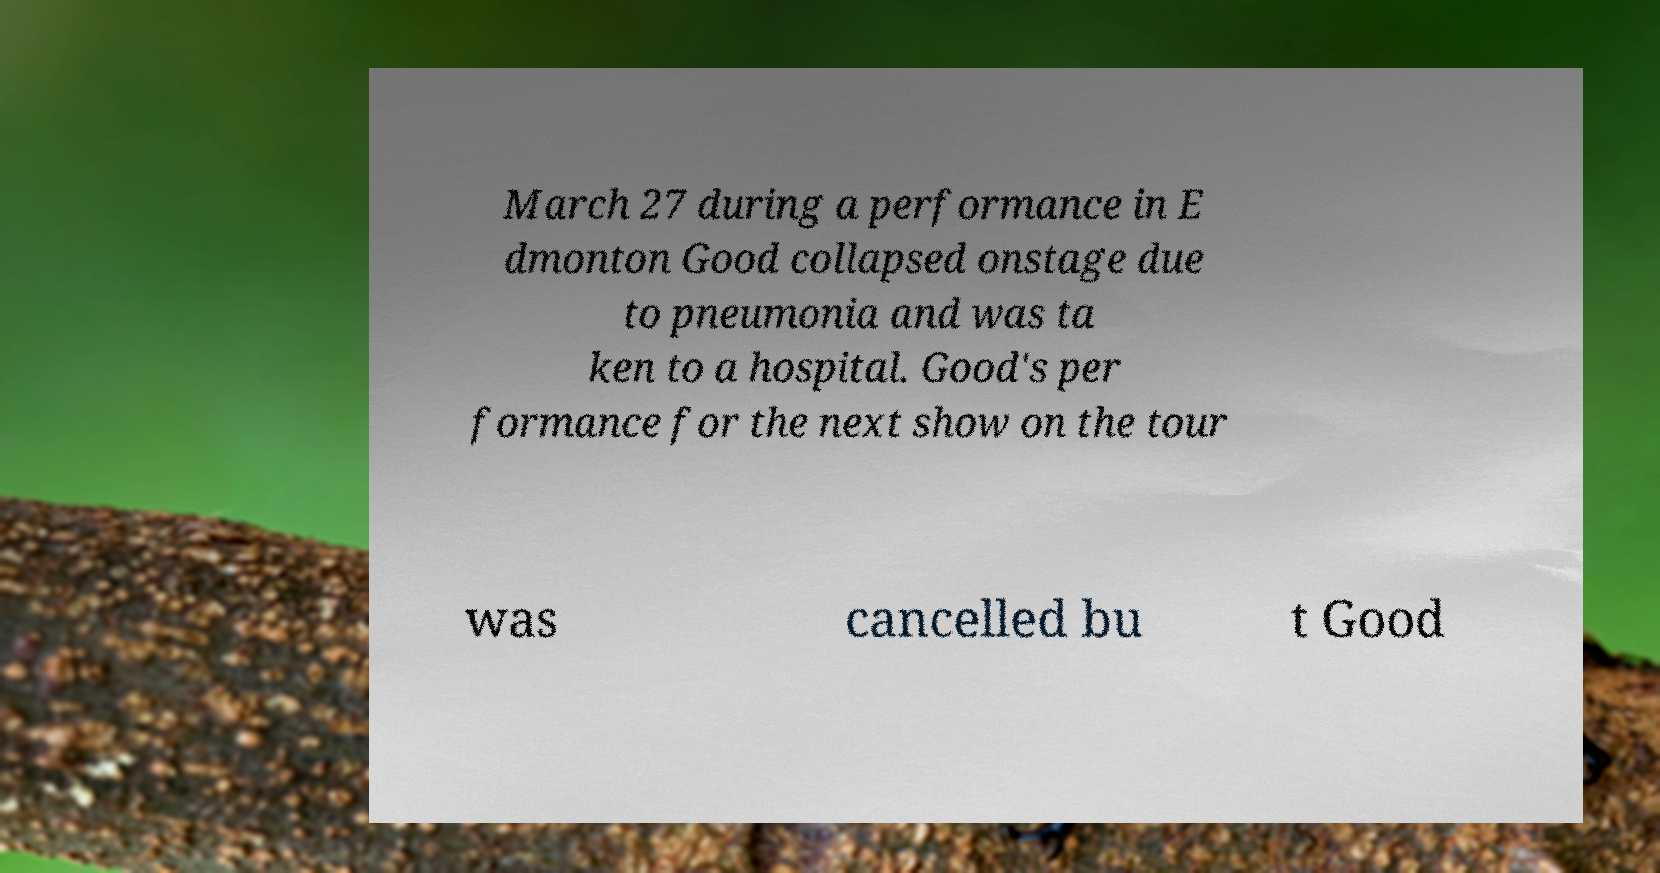Could you extract and type out the text from this image? March 27 during a performance in E dmonton Good collapsed onstage due to pneumonia and was ta ken to a hospital. Good's per formance for the next show on the tour was cancelled bu t Good 